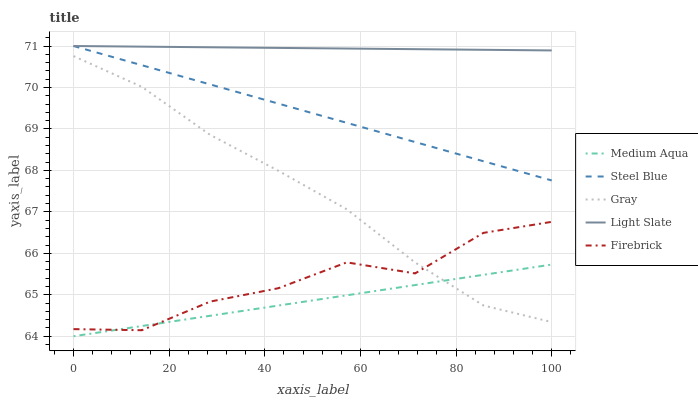Does Medium Aqua have the minimum area under the curve?
Answer yes or no. Yes. Does Light Slate have the maximum area under the curve?
Answer yes or no. Yes. Does Gray have the minimum area under the curve?
Answer yes or no. No. Does Gray have the maximum area under the curve?
Answer yes or no. No. Is Medium Aqua the smoothest?
Answer yes or no. Yes. Is Firebrick the roughest?
Answer yes or no. Yes. Is Gray the smoothest?
Answer yes or no. No. Is Gray the roughest?
Answer yes or no. No. Does Medium Aqua have the lowest value?
Answer yes or no. Yes. Does Gray have the lowest value?
Answer yes or no. No. Does Steel Blue have the highest value?
Answer yes or no. Yes. Does Gray have the highest value?
Answer yes or no. No. Is Gray less than Steel Blue?
Answer yes or no. Yes. Is Steel Blue greater than Gray?
Answer yes or no. Yes. Does Medium Aqua intersect Gray?
Answer yes or no. Yes. Is Medium Aqua less than Gray?
Answer yes or no. No. Is Medium Aqua greater than Gray?
Answer yes or no. No. Does Gray intersect Steel Blue?
Answer yes or no. No. 